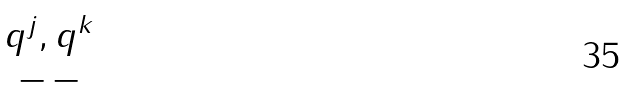Convert formula to latex. <formula><loc_0><loc_0><loc_500><loc_500>\begin{matrix} q ^ { j } , q ^ { k } \\ - \, - \end{matrix}</formula> 